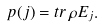Convert formula to latex. <formula><loc_0><loc_0><loc_500><loc_500>p ( j ) = t r \, \rho E _ { j } .</formula> 